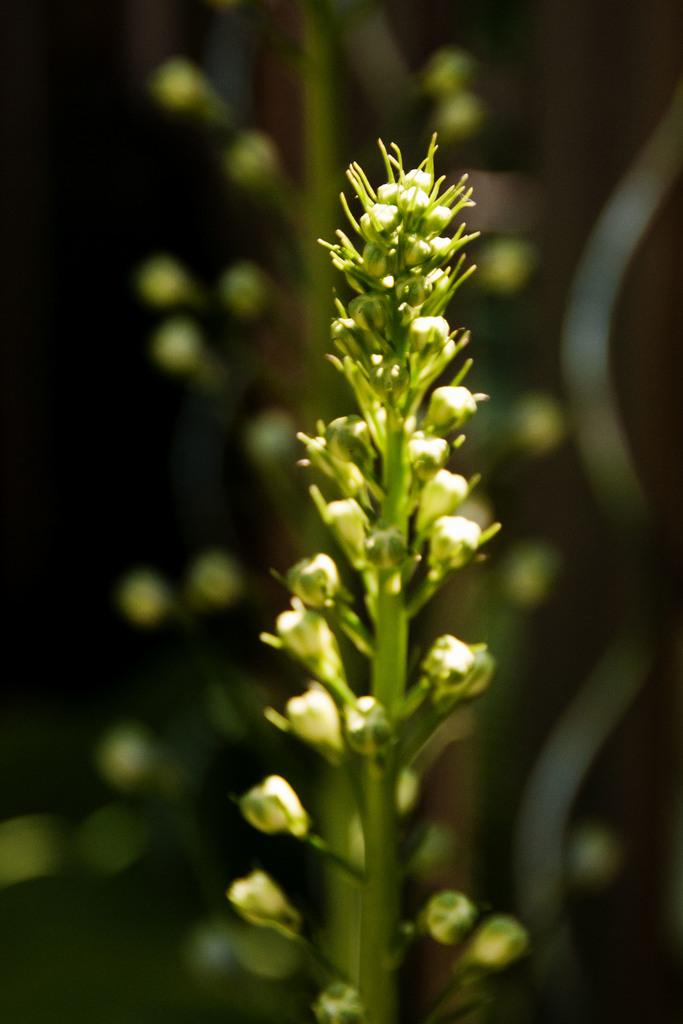What is the main subject in the front of the image? There is a plant in the front of the image. Can you describe the background of the image? The background of the image is blurry. What type of book is being read during the feast in the image? There is no book, feast, or reading activity present in the image; it only features a plant and a blurry background. 